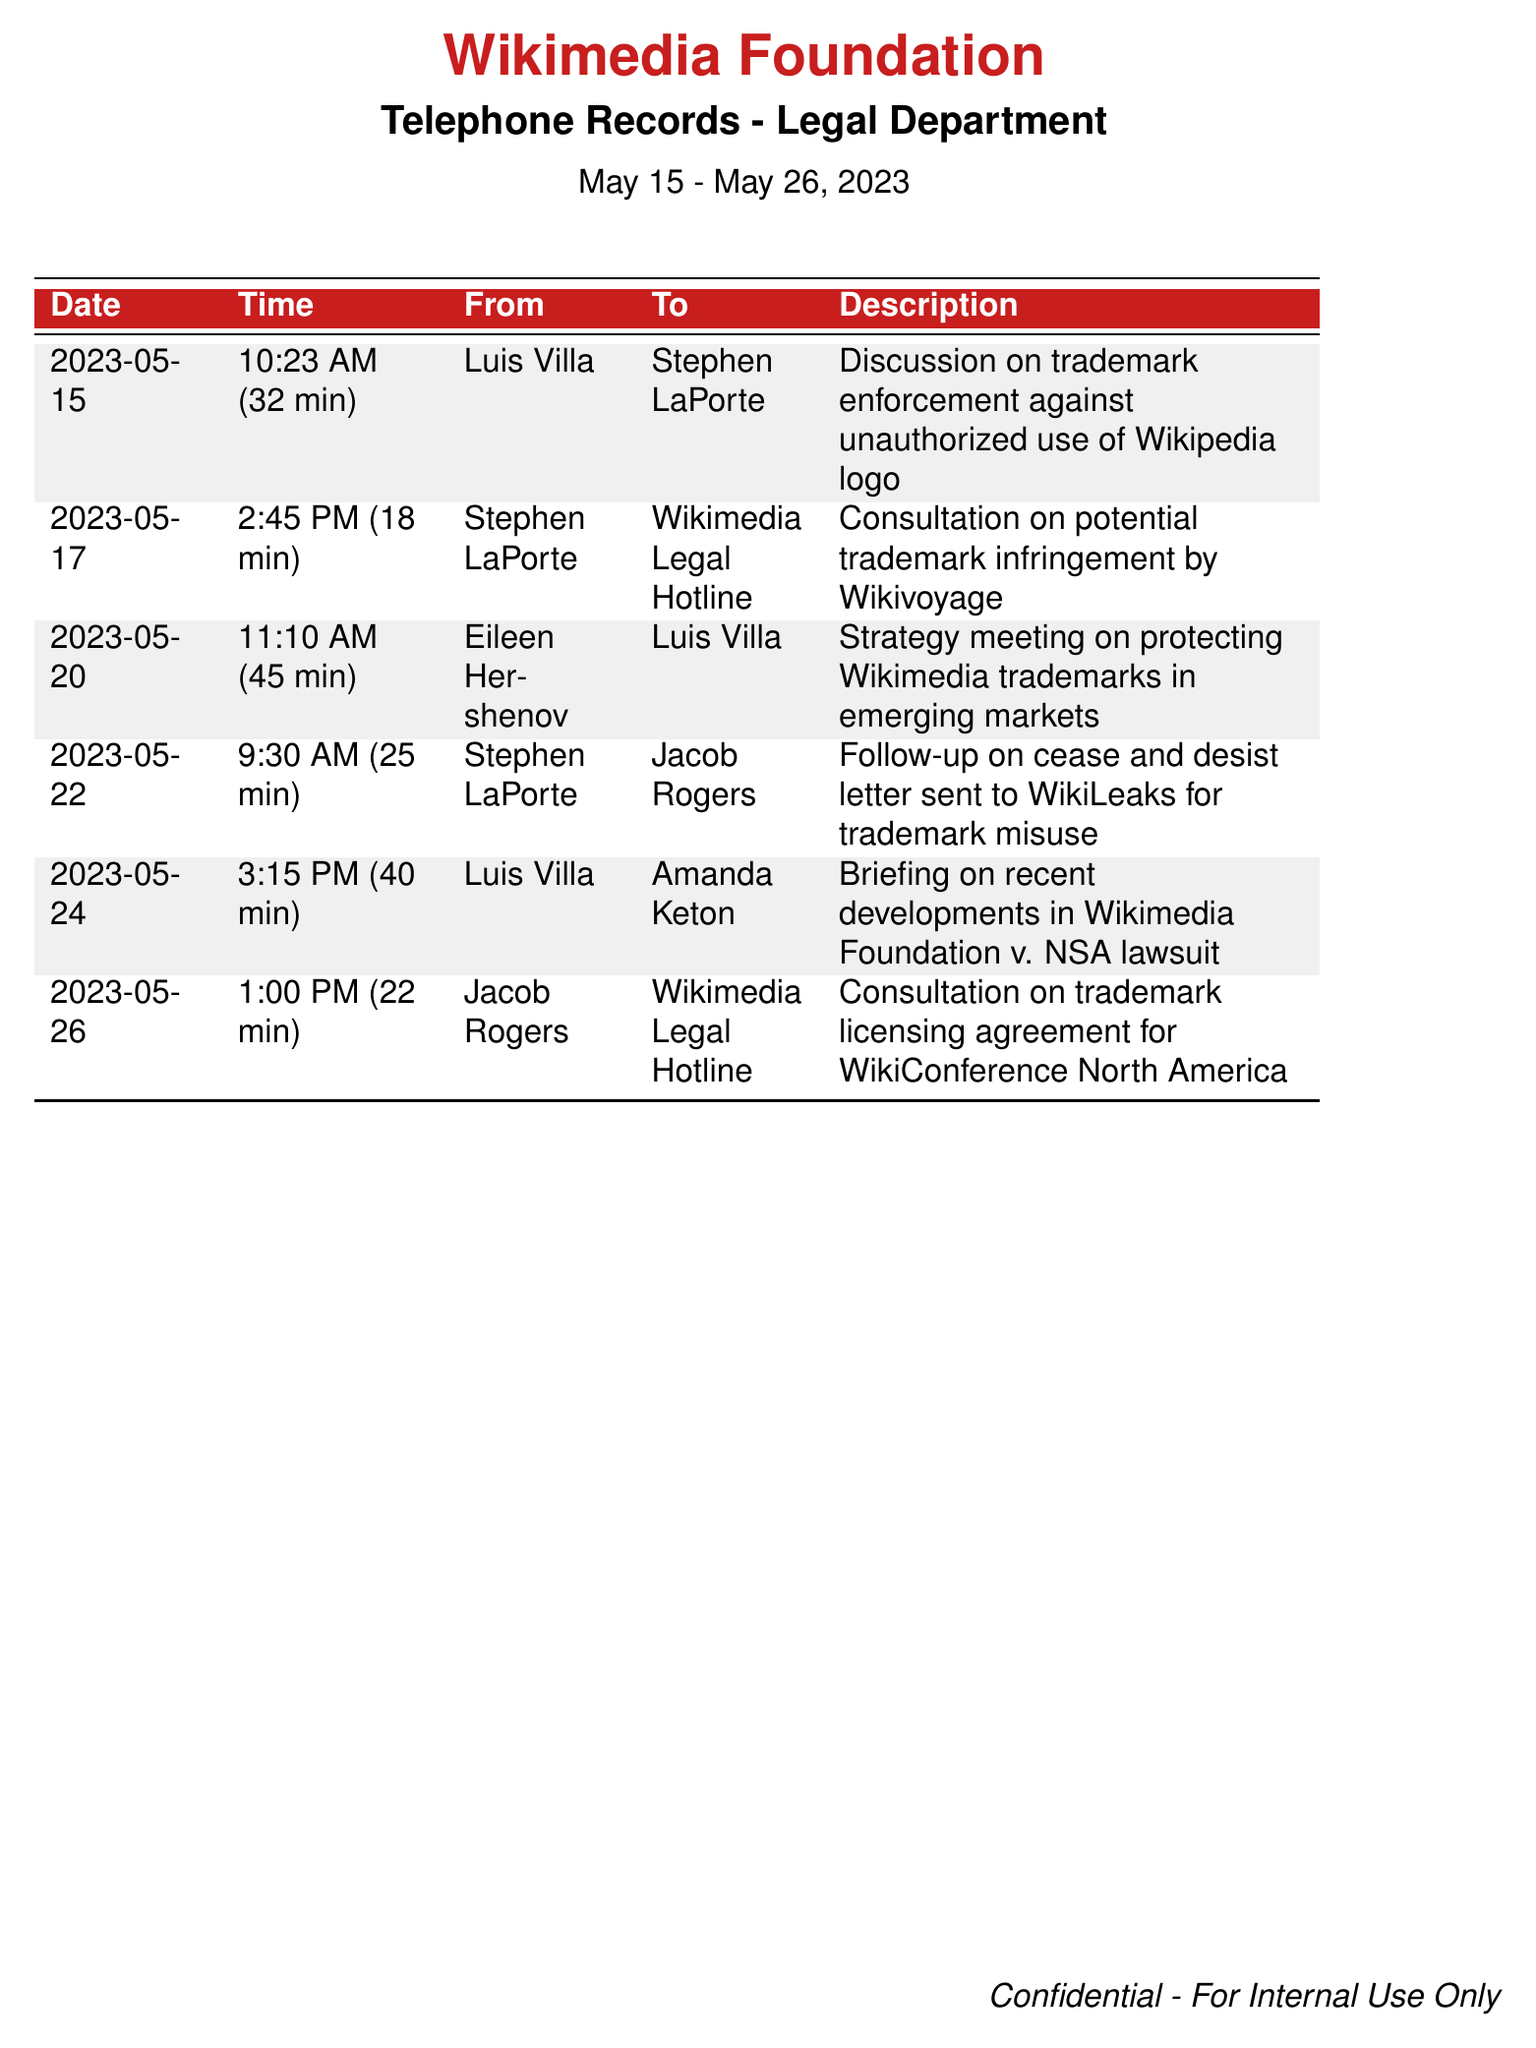what is the date of the first recorded call? The first recorded call in the document is on May 15, 2023.
Answer: May 15, 2023 who spoke with Stephen LaPorte on May 15? Stephen LaPorte spoke with Luis Villa on May 15.
Answer: Luis Villa how long was the call on May 20? The call on May 20 lasted 45 minutes.
Answer: 45 min what was the topic discussed in the call on May 22? The topic discussed in the call on May 22 was a follow-up on a cease and desist letter sent to WikiLeaks for trademark misuse.
Answer: Follow-up on cease and desist letter to WikiLeaks which team member spoke with Jacob Rogers on May 26? Jacob Rogers spoke with the Wikimedia Legal Hotline on May 26.
Answer: Wikimedia Legal Hotline how many calls involved trademark consultations? There were four calls that involved trademark consultations.
Answer: Four which call lasted the longest? The call that lasted the longest was on May 20, lasting 45 minutes.
Answer: May 20 who participated in the strategy meeting on May 20? Eileen Hershenov and Luis Villa participated in the strategy meeting on May 20.
Answer: Eileen Hershenov, Luis Villa what is the purpose of the records in this document? The records document legal communication regarding trademark issues pertaining to the Wikimedia Foundation.
Answer: Legal communication on trademark issues 